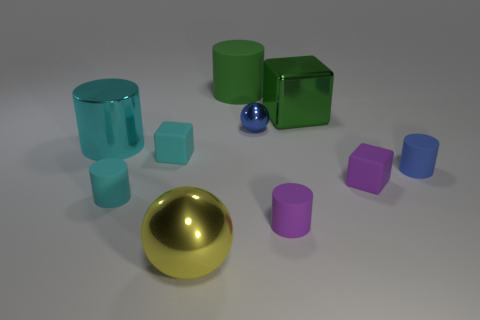How many objects are either blue metallic balls or gray rubber spheres?
Provide a short and direct response. 1. What number of large cyan objects are the same shape as the big yellow metal object?
Provide a succinct answer. 0. Do the small cyan cylinder and the tiny blue thing that is left of the purple cylinder have the same material?
Offer a very short reply. No. The cyan thing that is the same material as the large green block is what size?
Make the answer very short. Large. What is the size of the purple object that is left of the purple matte block?
Provide a short and direct response. Small. What number of blue shiny cylinders are the same size as the cyan metallic cylinder?
Your answer should be compact. 0. What is the size of the matte block that is the same color as the large shiny cylinder?
Make the answer very short. Small. Are there any big cylinders that have the same color as the big sphere?
Keep it short and to the point. No. What color is the block that is the same size as the yellow metallic object?
Your answer should be compact. Green. Does the tiny metal ball have the same color as the cube left of the big matte thing?
Provide a short and direct response. No. 